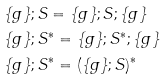<formula> <loc_0><loc_0><loc_500><loc_500>& \{ g \} ; S = \{ g \} ; S ; \{ g \} \\ & \{ g \} ; S ^ { * } = \{ g \} ; S ^ { * } ; \{ g \} \\ & \{ g \} ; S ^ { * } = ( \{ g \} ; S ) ^ { * }</formula> 